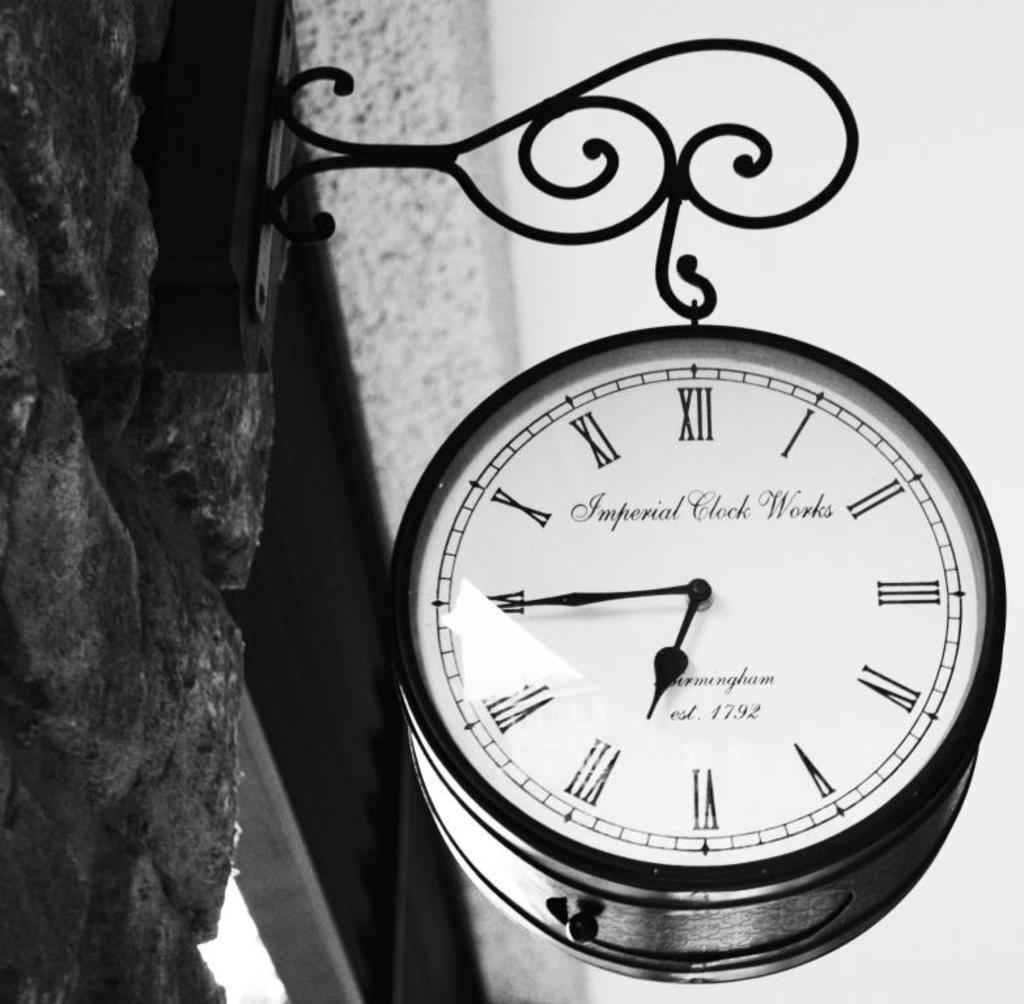<image>
Render a clear and concise summary of the photo. An Imperial Clock Works clock hangs from a stone building. 